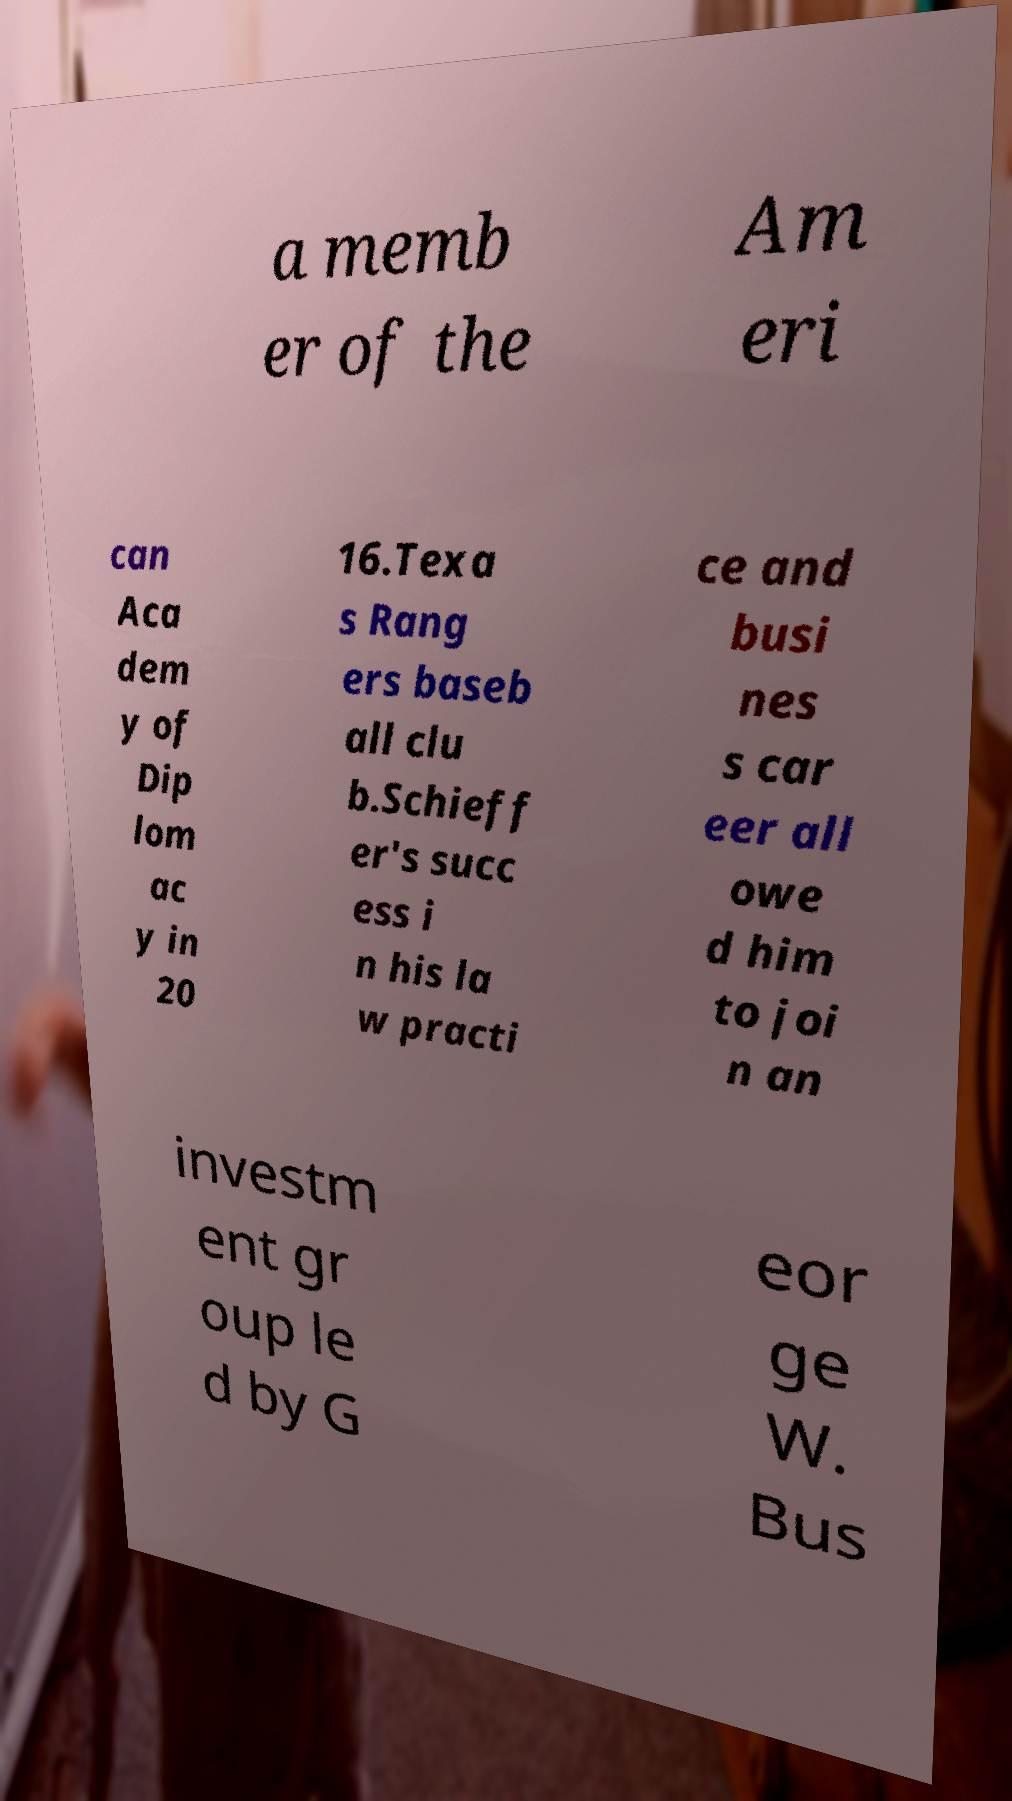Could you extract and type out the text from this image? a memb er of the Am eri can Aca dem y of Dip lom ac y in 20 16.Texa s Rang ers baseb all clu b.Schieff er's succ ess i n his la w practi ce and busi nes s car eer all owe d him to joi n an investm ent gr oup le d by G eor ge W. Bus 